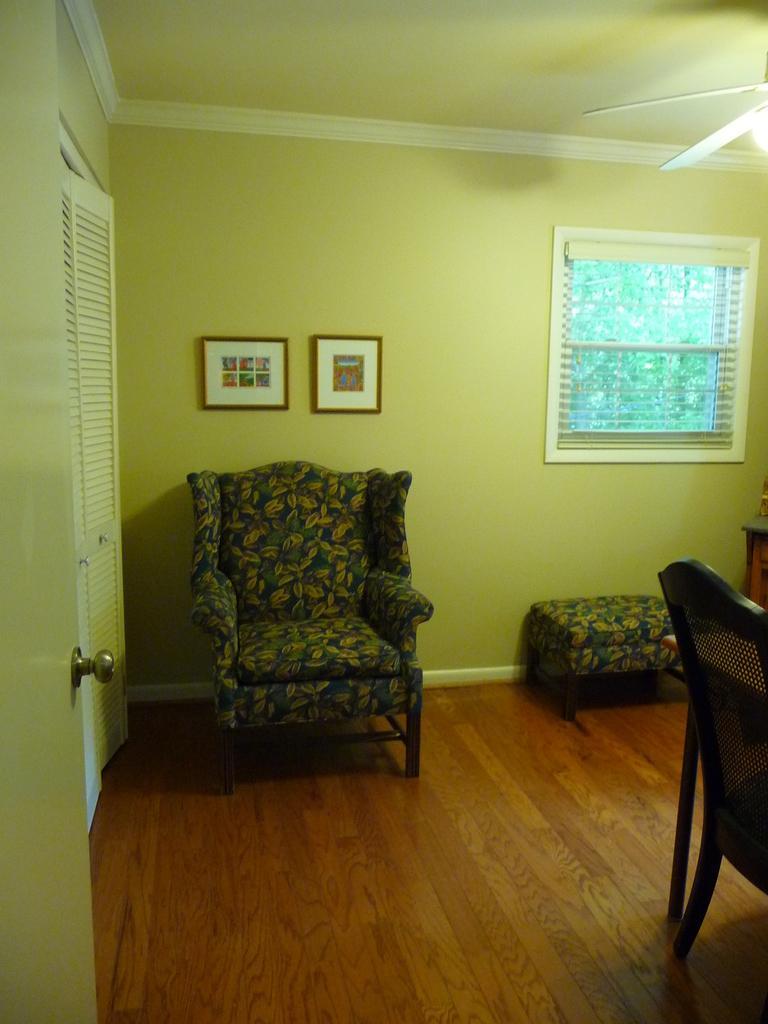Can you describe this image briefly? In this image, we can see walls, doors, window, window shade, photo frames, chairs, table and stool. Here we can see wooden floor. Top of the image, we can see the ceiling, ceiling fan and light. 